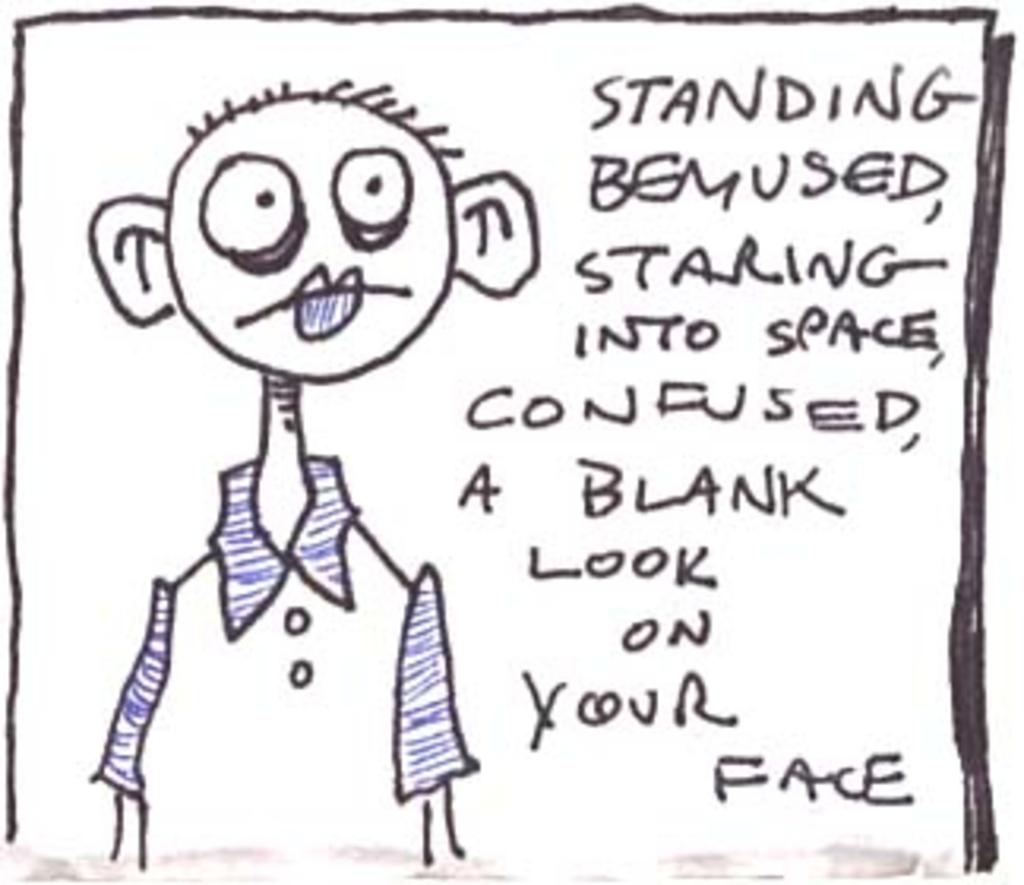What type of image is depicted in the picture? There is a cartoon drawing in the image. What else can be seen in the image besides the cartoon drawing? There is something written on a paper in the image. How does the cartoon character feel about their upcoming holiday? There is no information about a holiday or the cartoon character's feelings in the image. 